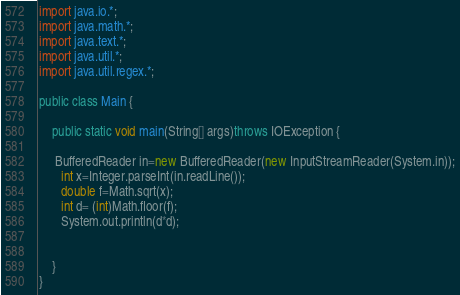Convert code to text. <code><loc_0><loc_0><loc_500><loc_500><_Java_>import java.io.*;
import java.math.*;
import java.text.*;
import java.util.*;
import java.util.regex.*;

public class Main {
 
    public static void main(String[] args)throws IOException {
        
     BufferedReader in=new BufferedReader(new InputStreamReader(System.in));
       int x=Integer.parseInt(in.readLine());
       double f=Math.sqrt(x);
       int d= (int)Math.floor(f);
       System.out.println(d*d);


    }
}
</code> 